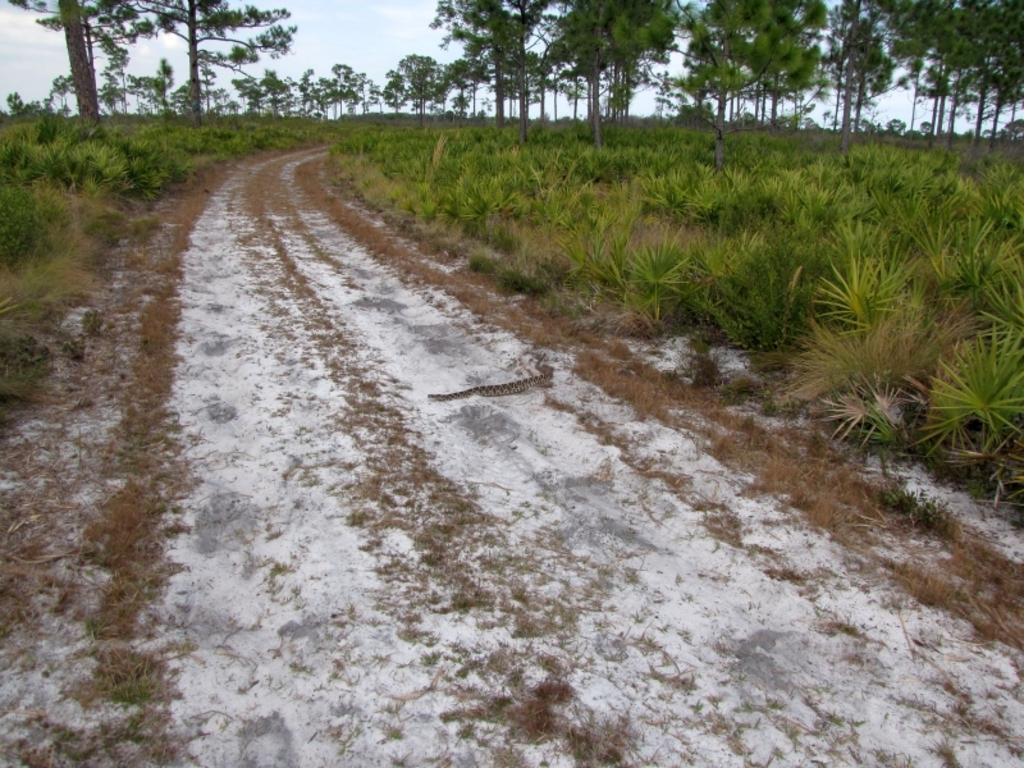What can be seen in the image that people might walk on? There is a path in the image that people might walk on. What is around the path in the image? The path is surrounded by plants and trees. What is visible in the sky in the image? There are clouds visible in the sky. What type of food is being harvested from the celery in the image? There is no celery present in the image, and therefore no food can be harvested from it. 